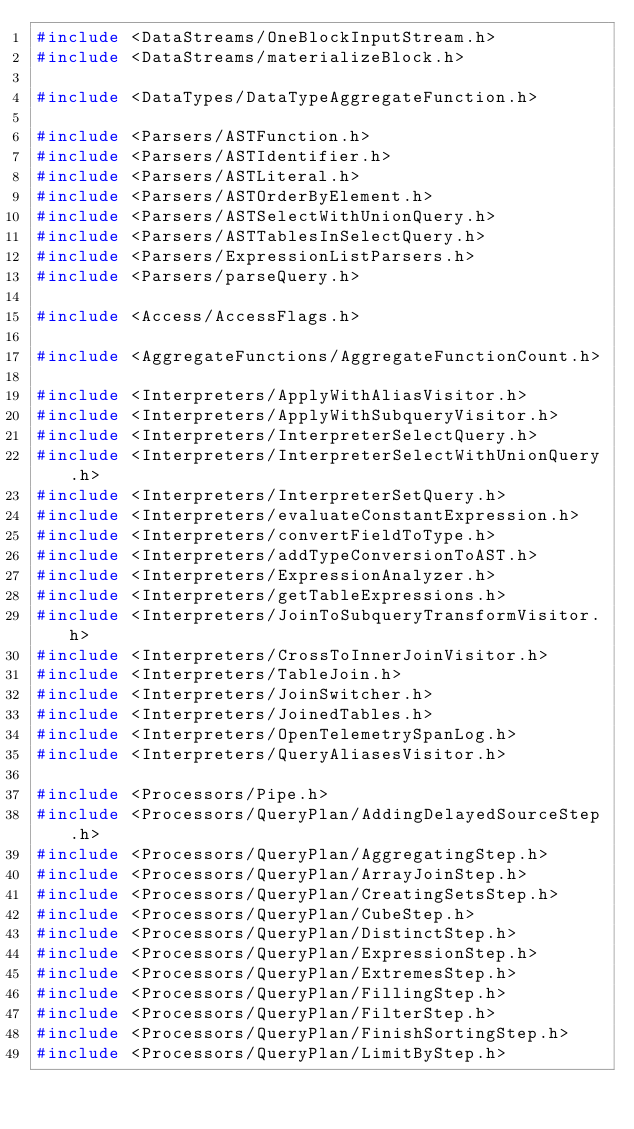Convert code to text. <code><loc_0><loc_0><loc_500><loc_500><_C++_>#include <DataStreams/OneBlockInputStream.h>
#include <DataStreams/materializeBlock.h>

#include <DataTypes/DataTypeAggregateFunction.h>

#include <Parsers/ASTFunction.h>
#include <Parsers/ASTIdentifier.h>
#include <Parsers/ASTLiteral.h>
#include <Parsers/ASTOrderByElement.h>
#include <Parsers/ASTSelectWithUnionQuery.h>
#include <Parsers/ASTTablesInSelectQuery.h>
#include <Parsers/ExpressionListParsers.h>
#include <Parsers/parseQuery.h>

#include <Access/AccessFlags.h>

#include <AggregateFunctions/AggregateFunctionCount.h>

#include <Interpreters/ApplyWithAliasVisitor.h>
#include <Interpreters/ApplyWithSubqueryVisitor.h>
#include <Interpreters/InterpreterSelectQuery.h>
#include <Interpreters/InterpreterSelectWithUnionQuery.h>
#include <Interpreters/InterpreterSetQuery.h>
#include <Interpreters/evaluateConstantExpression.h>
#include <Interpreters/convertFieldToType.h>
#include <Interpreters/addTypeConversionToAST.h>
#include <Interpreters/ExpressionAnalyzer.h>
#include <Interpreters/getTableExpressions.h>
#include <Interpreters/JoinToSubqueryTransformVisitor.h>
#include <Interpreters/CrossToInnerJoinVisitor.h>
#include <Interpreters/TableJoin.h>
#include <Interpreters/JoinSwitcher.h>
#include <Interpreters/JoinedTables.h>
#include <Interpreters/OpenTelemetrySpanLog.h>
#include <Interpreters/QueryAliasesVisitor.h>

#include <Processors/Pipe.h>
#include <Processors/QueryPlan/AddingDelayedSourceStep.h>
#include <Processors/QueryPlan/AggregatingStep.h>
#include <Processors/QueryPlan/ArrayJoinStep.h>
#include <Processors/QueryPlan/CreatingSetsStep.h>
#include <Processors/QueryPlan/CubeStep.h>
#include <Processors/QueryPlan/DistinctStep.h>
#include <Processors/QueryPlan/ExpressionStep.h>
#include <Processors/QueryPlan/ExtremesStep.h>
#include <Processors/QueryPlan/FillingStep.h>
#include <Processors/QueryPlan/FilterStep.h>
#include <Processors/QueryPlan/FinishSortingStep.h>
#include <Processors/QueryPlan/LimitByStep.h></code> 